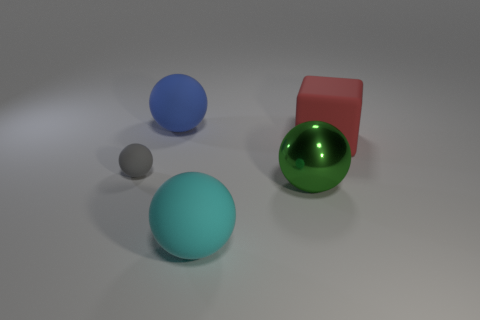Subtract 1 balls. How many balls are left? 3 Add 4 green things. How many objects exist? 9 Subtract all blocks. How many objects are left? 4 Add 1 large green metallic spheres. How many large green metallic spheres exist? 2 Subtract 0 gray cylinders. How many objects are left? 5 Subtract all small balls. Subtract all big green balls. How many objects are left? 3 Add 4 matte spheres. How many matte spheres are left? 7 